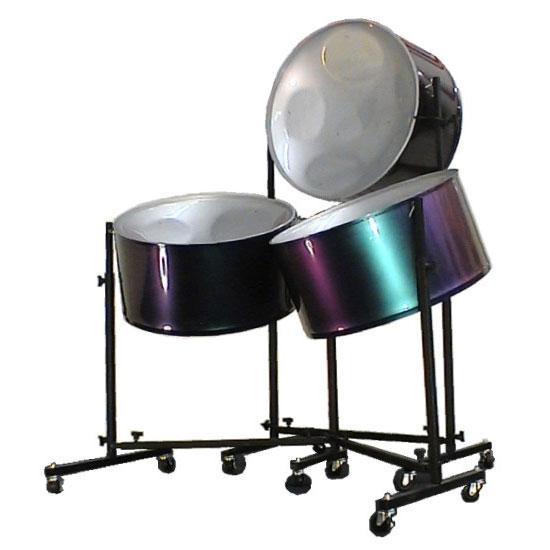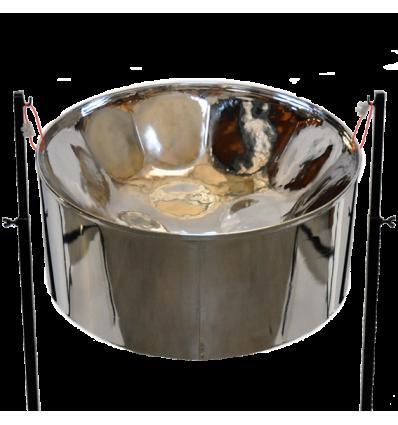The first image is the image on the left, the second image is the image on the right. Evaluate the accuracy of this statement regarding the images: "One image features a pair of drums wrapped in pale cord, with pillow bases and flat tops with black dots in the center, and the other image is a pair of side-by-side shiny bowl-shaped steel drums.". Is it true? Answer yes or no. No. The first image is the image on the left, the second image is the image on the right. Examine the images to the left and right. Is the description "a set of drums have a dark circle on top, and leather strips around the drum holding wooden dowels" accurate? Answer yes or no. No. 